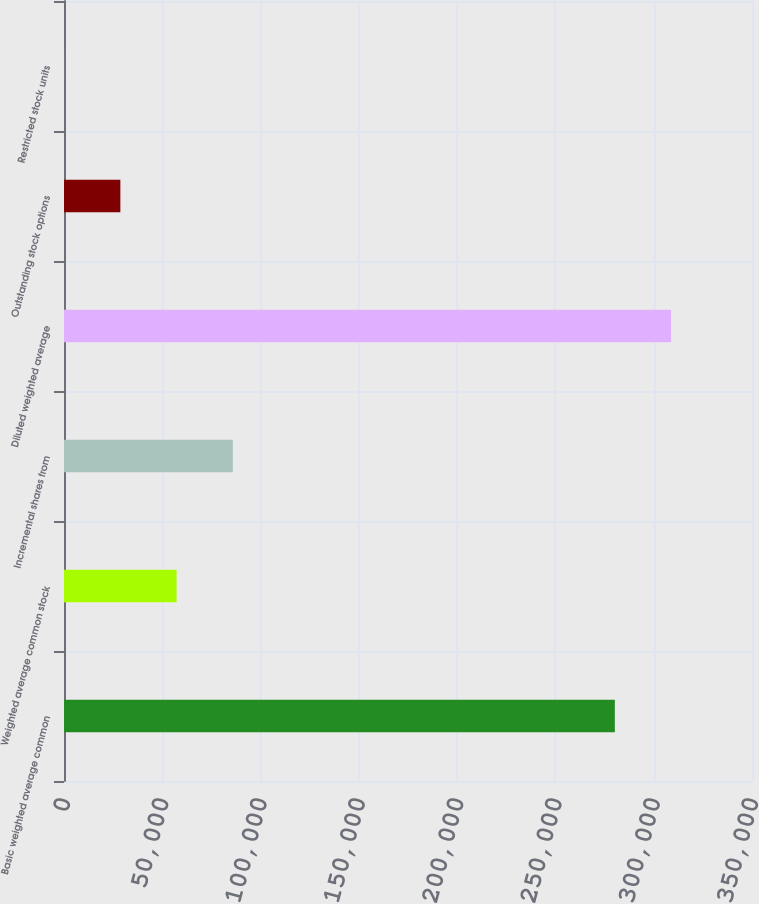<chart> <loc_0><loc_0><loc_500><loc_500><bar_chart><fcel>Basic weighted average common<fcel>Weighted average common stock<fcel>Incremental shares from<fcel>Diluted weighted average<fcel>Outstanding stock options<fcel>Restricted stock units<nl><fcel>280213<fcel>57280.8<fcel>85890.2<fcel>308822<fcel>28671.4<fcel>62<nl></chart> 